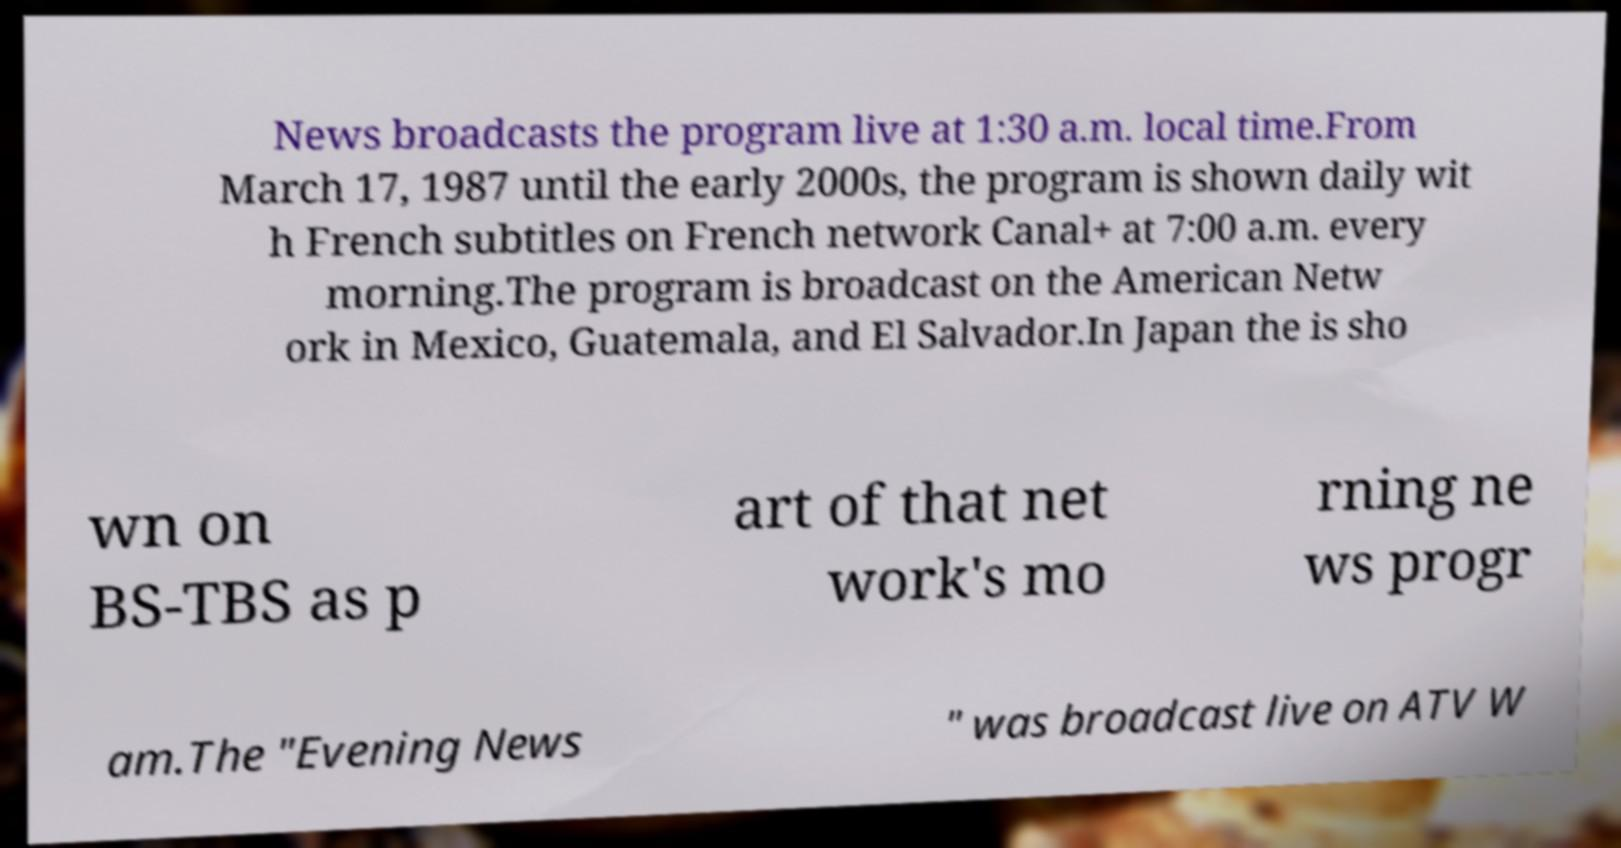Can you accurately transcribe the text from the provided image for me? News broadcasts the program live at 1:30 a.m. local time.From March 17, 1987 until the early 2000s, the program is shown daily wit h French subtitles on French network Canal+ at 7:00 a.m. every morning.The program is broadcast on the American Netw ork in Mexico, Guatemala, and El Salvador.In Japan the is sho wn on BS-TBS as p art of that net work's mo rning ne ws progr am.The "Evening News " was broadcast live on ATV W 